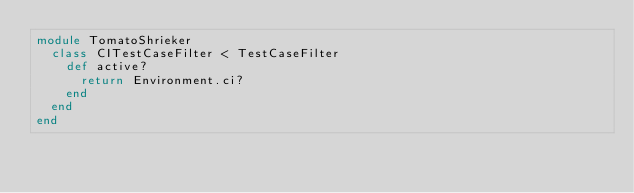Convert code to text. <code><loc_0><loc_0><loc_500><loc_500><_Ruby_>module TomatoShrieker
  class CITestCaseFilter < TestCaseFilter
    def active?
      return Environment.ci?
    end
  end
end
</code> 